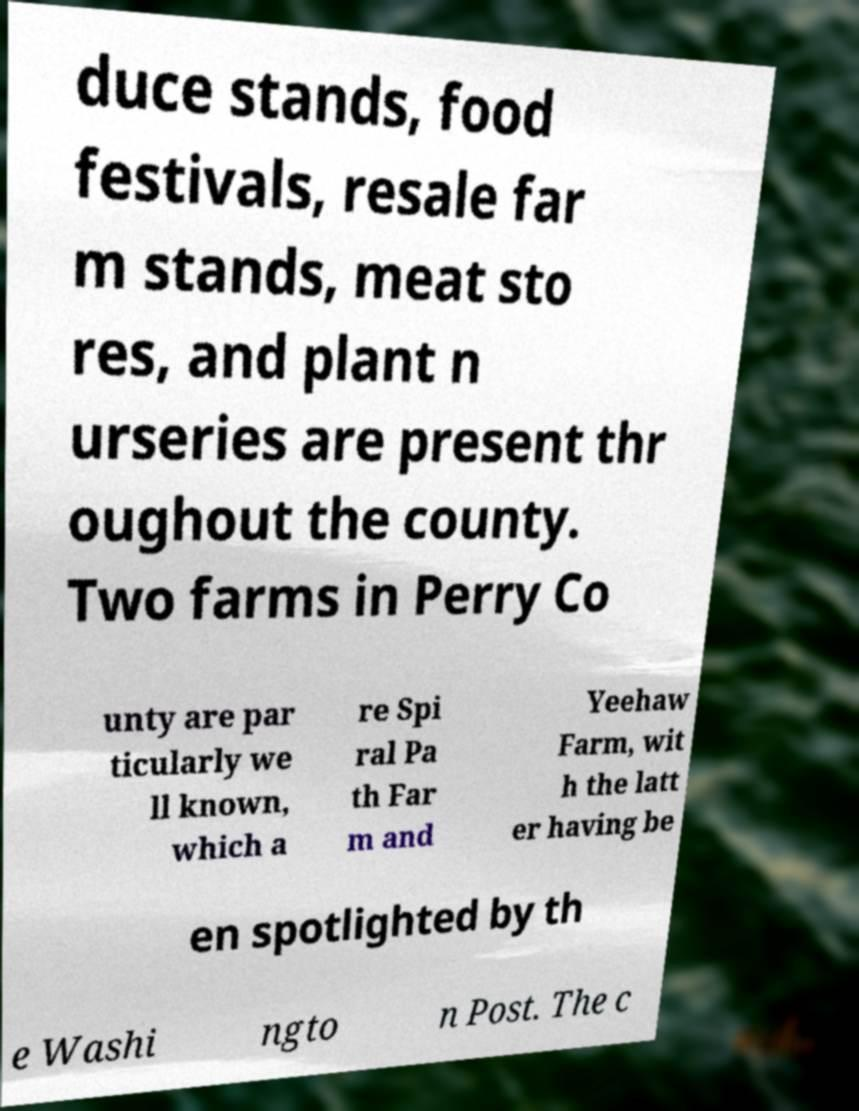I need the written content from this picture converted into text. Can you do that? duce stands, food festivals, resale far m stands, meat sto res, and plant n urseries are present thr oughout the county. Two farms in Perry Co unty are par ticularly we ll known, which a re Spi ral Pa th Far m and Yeehaw Farm, wit h the latt er having be en spotlighted by th e Washi ngto n Post. The c 